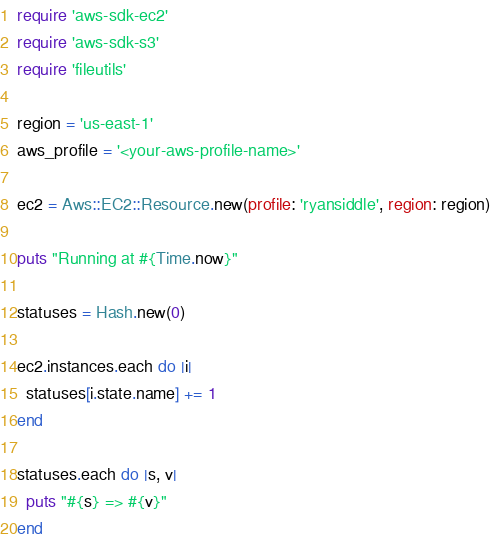Convert code to text. <code><loc_0><loc_0><loc_500><loc_500><_Ruby_>require 'aws-sdk-ec2'
require 'aws-sdk-s3'
require 'fileutils'

region = 'us-east-1'
aws_profile = '<your-aws-profile-name>'

ec2 = Aws::EC2::Resource.new(profile: 'ryansiddle', region: region)

puts "Running at #{Time.now}"

statuses = Hash.new(0)

ec2.instances.each do |i|
  statuses[i.state.name] += 1
end

statuses.each do |s, v|
  puts "#{s} => #{v}"
end</code> 